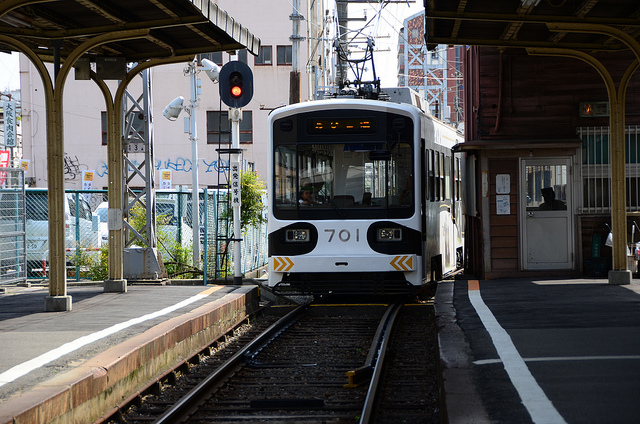Please extract the text content from this image. 701 